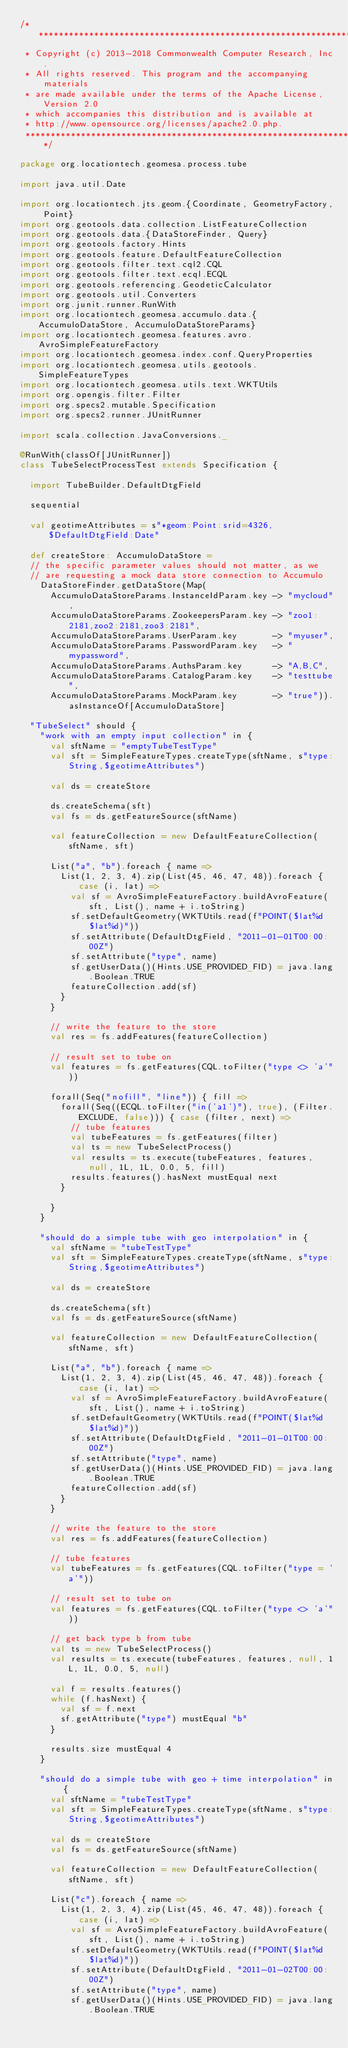<code> <loc_0><loc_0><loc_500><loc_500><_Scala_>/***********************************************************************
 * Copyright (c) 2013-2018 Commonwealth Computer Research, Inc.
 * All rights reserved. This program and the accompanying materials
 * are made available under the terms of the Apache License, Version 2.0
 * which accompanies this distribution and is available at
 * http://www.opensource.org/licenses/apache2.0.php.
 ***********************************************************************/

package org.locationtech.geomesa.process.tube

import java.util.Date

import org.locationtech.jts.geom.{Coordinate, GeometryFactory, Point}
import org.geotools.data.collection.ListFeatureCollection
import org.geotools.data.{DataStoreFinder, Query}
import org.geotools.factory.Hints
import org.geotools.feature.DefaultFeatureCollection
import org.geotools.filter.text.cql2.CQL
import org.geotools.filter.text.ecql.ECQL
import org.geotools.referencing.GeodeticCalculator
import org.geotools.util.Converters
import org.junit.runner.RunWith
import org.locationtech.geomesa.accumulo.data.{AccumuloDataStore, AccumuloDataStoreParams}
import org.locationtech.geomesa.features.avro.AvroSimpleFeatureFactory
import org.locationtech.geomesa.index.conf.QueryProperties
import org.locationtech.geomesa.utils.geotools.SimpleFeatureTypes
import org.locationtech.geomesa.utils.text.WKTUtils
import org.opengis.filter.Filter
import org.specs2.mutable.Specification
import org.specs2.runner.JUnitRunner

import scala.collection.JavaConversions._

@RunWith(classOf[JUnitRunner])
class TubeSelectProcessTest extends Specification {

  import TubeBuilder.DefaultDtgField

  sequential

  val geotimeAttributes = s"*geom:Point:srid=4326,$DefaultDtgField:Date"

  def createStore: AccumuloDataStore =
  // the specific parameter values should not matter, as we
  // are requesting a mock data store connection to Accumulo
    DataStoreFinder.getDataStore(Map(
      AccumuloDataStoreParams.InstanceIdParam.key -> "mycloud",
      AccumuloDataStoreParams.ZookeepersParam.key -> "zoo1:2181,zoo2:2181,zoo3:2181",
      AccumuloDataStoreParams.UserParam.key       -> "myuser",
      AccumuloDataStoreParams.PasswordParam.key   -> "mypassword",
      AccumuloDataStoreParams.AuthsParam.key      -> "A,B,C",
      AccumuloDataStoreParams.CatalogParam.key    -> "testtube",
      AccumuloDataStoreParams.MockParam.key       -> "true")).asInstanceOf[AccumuloDataStore]

  "TubeSelect" should {
    "work with an empty input collection" in {
      val sftName = "emptyTubeTestType"
      val sft = SimpleFeatureTypes.createType(sftName, s"type:String,$geotimeAttributes")

      val ds = createStore

      ds.createSchema(sft)
      val fs = ds.getFeatureSource(sftName)

      val featureCollection = new DefaultFeatureCollection(sftName, sft)

      List("a", "b").foreach { name =>
        List(1, 2, 3, 4).zip(List(45, 46, 47, 48)).foreach { case (i, lat) =>
          val sf = AvroSimpleFeatureFactory.buildAvroFeature(sft, List(), name + i.toString)
          sf.setDefaultGeometry(WKTUtils.read(f"POINT($lat%d $lat%d)"))
          sf.setAttribute(DefaultDtgField, "2011-01-01T00:00:00Z")
          sf.setAttribute("type", name)
          sf.getUserData()(Hints.USE_PROVIDED_FID) = java.lang.Boolean.TRUE
          featureCollection.add(sf)
        }
      }

      // write the feature to the store
      val res = fs.addFeatures(featureCollection)

      // result set to tube on
      val features = fs.getFeatures(CQL.toFilter("type <> 'a'"))

      forall(Seq("nofill", "line")) { fill =>
        forall(Seq((ECQL.toFilter("in('a1')"), true), (Filter.EXCLUDE, false))) { case (filter, next) =>
          // tube features
          val tubeFeatures = fs.getFeatures(filter)
          val ts = new TubeSelectProcess()
          val results = ts.execute(tubeFeatures, features, null, 1L, 1L, 0.0, 5, fill)
          results.features().hasNext mustEqual next
        }

      }
    }

    "should do a simple tube with geo interpolation" in {
      val sftName = "tubeTestType"
      val sft = SimpleFeatureTypes.createType(sftName, s"type:String,$geotimeAttributes")

      val ds = createStore

      ds.createSchema(sft)
      val fs = ds.getFeatureSource(sftName)

      val featureCollection = new DefaultFeatureCollection(sftName, sft)

      List("a", "b").foreach { name =>
        List(1, 2, 3, 4).zip(List(45, 46, 47, 48)).foreach { case (i, lat) =>
          val sf = AvroSimpleFeatureFactory.buildAvroFeature(sft, List(), name + i.toString)
          sf.setDefaultGeometry(WKTUtils.read(f"POINT($lat%d $lat%d)"))
          sf.setAttribute(DefaultDtgField, "2011-01-01T00:00:00Z")
          sf.setAttribute("type", name)
          sf.getUserData()(Hints.USE_PROVIDED_FID) = java.lang.Boolean.TRUE
          featureCollection.add(sf)
        }
      }

      // write the feature to the store
      val res = fs.addFeatures(featureCollection)

      // tube features
      val tubeFeatures = fs.getFeatures(CQL.toFilter("type = 'a'"))

      // result set to tube on
      val features = fs.getFeatures(CQL.toFilter("type <> 'a'"))

      // get back type b from tube
      val ts = new TubeSelectProcess()
      val results = ts.execute(tubeFeatures, features, null, 1L, 1L, 0.0, 5, null)

      val f = results.features()
      while (f.hasNext) {
        val sf = f.next
        sf.getAttribute("type") mustEqual "b"
      }

      results.size mustEqual 4
    }

    "should do a simple tube with geo + time interpolation" in {
      val sftName = "tubeTestType"
      val sft = SimpleFeatureTypes.createType(sftName, s"type:String,$geotimeAttributes")

      val ds = createStore
      val fs = ds.getFeatureSource(sftName)

      val featureCollection = new DefaultFeatureCollection(sftName, sft)

      List("c").foreach { name =>
        List(1, 2, 3, 4).zip(List(45, 46, 47, 48)).foreach { case (i, lat) =>
          val sf = AvroSimpleFeatureFactory.buildAvroFeature(sft, List(), name + i.toString)
          sf.setDefaultGeometry(WKTUtils.read(f"POINT($lat%d $lat%d)"))
          sf.setAttribute(DefaultDtgField, "2011-01-02T00:00:00Z")
          sf.setAttribute("type", name)
          sf.getUserData()(Hints.USE_PROVIDED_FID) = java.lang.Boolean.TRUE</code> 